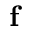<formula> <loc_0><loc_0><loc_500><loc_500>f</formula> 